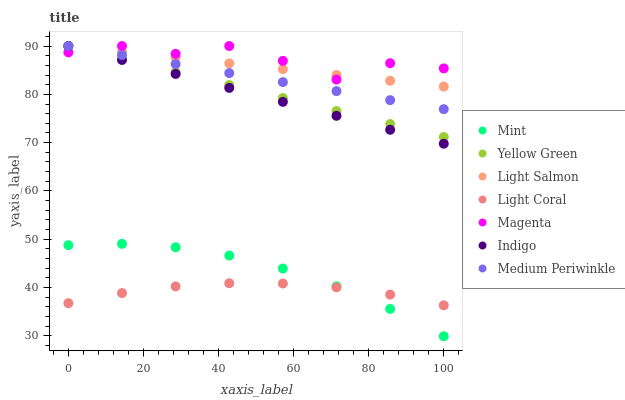Does Light Coral have the minimum area under the curve?
Answer yes or no. Yes. Does Magenta have the maximum area under the curve?
Answer yes or no. Yes. Does Indigo have the minimum area under the curve?
Answer yes or no. No. Does Indigo have the maximum area under the curve?
Answer yes or no. No. Is Indigo the smoothest?
Answer yes or no. Yes. Is Magenta the roughest?
Answer yes or no. Yes. Is Yellow Green the smoothest?
Answer yes or no. No. Is Yellow Green the roughest?
Answer yes or no. No. Does Mint have the lowest value?
Answer yes or no. Yes. Does Indigo have the lowest value?
Answer yes or no. No. Does Magenta have the highest value?
Answer yes or no. Yes. Does Light Coral have the highest value?
Answer yes or no. No. Is Mint less than Light Salmon?
Answer yes or no. Yes. Is Magenta greater than Mint?
Answer yes or no. Yes. Does Indigo intersect Light Salmon?
Answer yes or no. Yes. Is Indigo less than Light Salmon?
Answer yes or no. No. Is Indigo greater than Light Salmon?
Answer yes or no. No. Does Mint intersect Light Salmon?
Answer yes or no. No. 